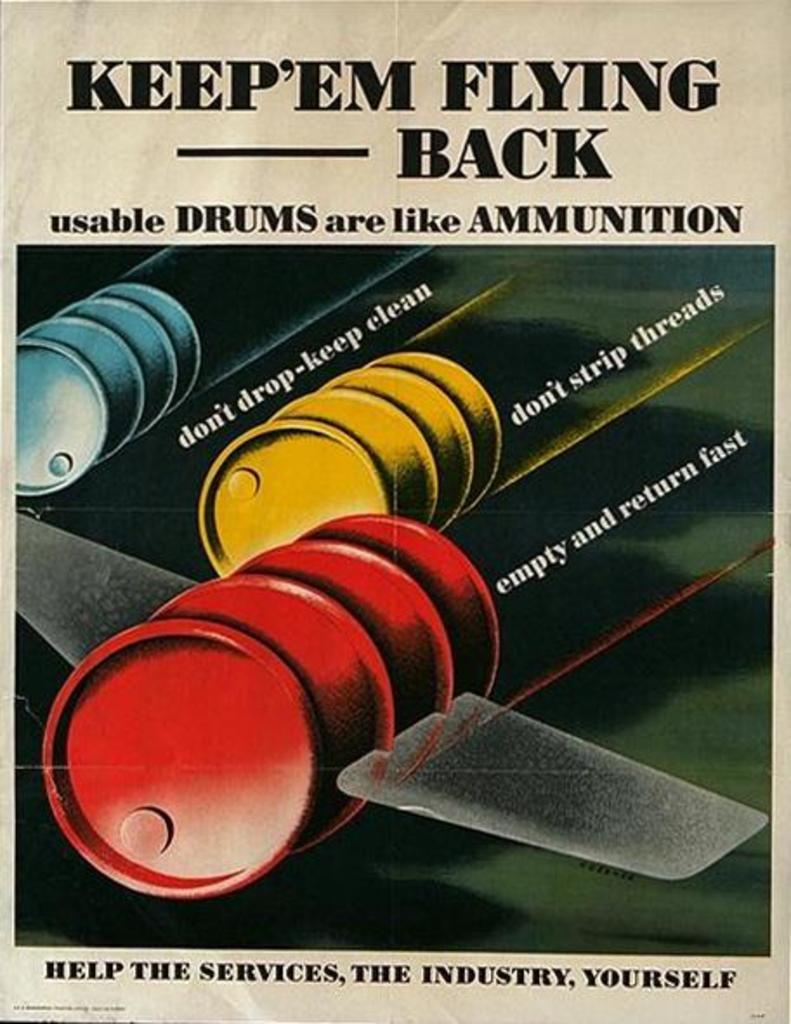<image>
Summarize the visual content of the image. An old colorful advertisement for usable drums with three drums on it 